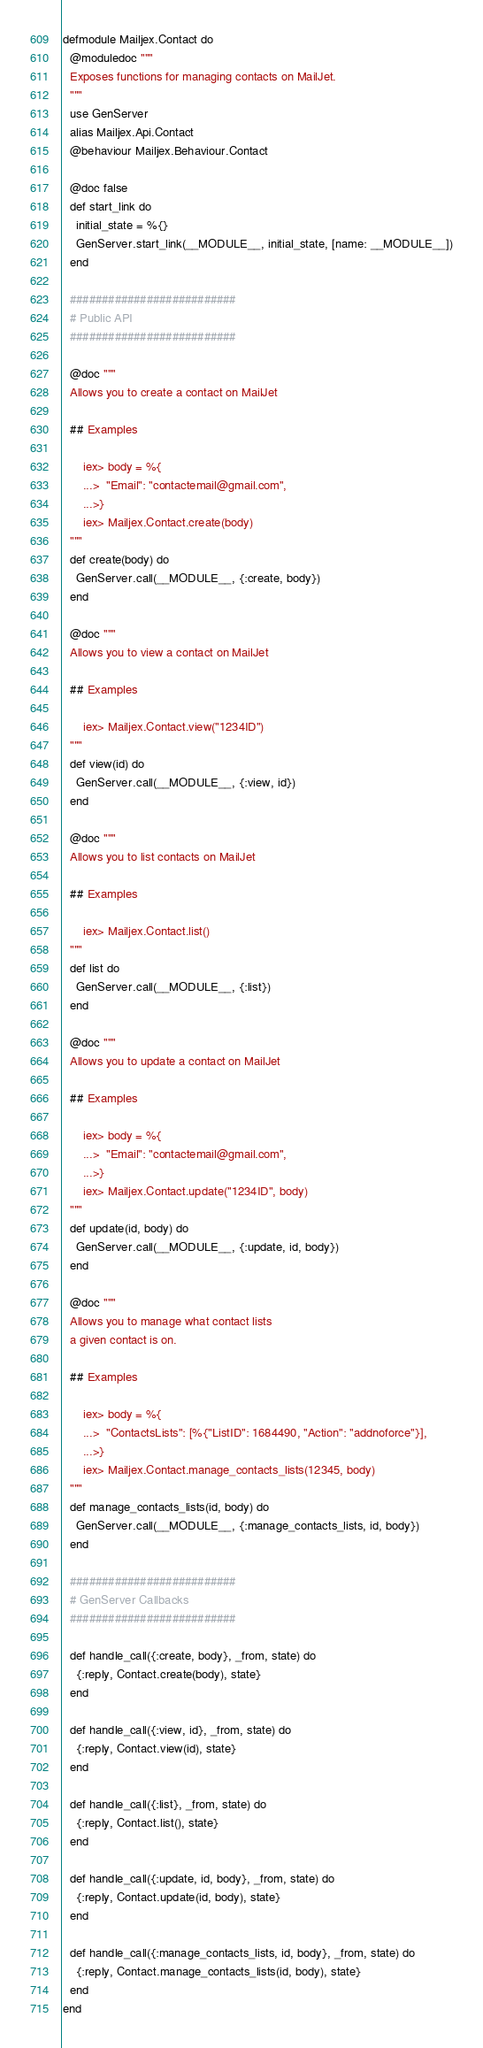Convert code to text. <code><loc_0><loc_0><loc_500><loc_500><_Elixir_>defmodule Mailjex.Contact do
  @moduledoc """
  Exposes functions for managing contacts on MailJet.
  """
  use GenServer
  alias Mailjex.Api.Contact
  @behaviour Mailjex.Behaviour.Contact

  @doc false
  def start_link do
    initial_state = %{}
    GenServer.start_link(__MODULE__, initial_state, [name: __MODULE__])
  end

  ##########################
  # Public API
  ##########################

  @doc """
  Allows you to create a contact on MailJet

  ## Examples

      iex> body = %{
      ...>  "Email": "contactemail@gmail.com",
      ...>}
      iex> Mailjex.Contact.create(body)
  """
  def create(body) do
    GenServer.call(__MODULE__, {:create, body})
  end

  @doc """
  Allows you to view a contact on MailJet

  ## Examples

      iex> Mailjex.Contact.view("1234ID")
  """
  def view(id) do
    GenServer.call(__MODULE__, {:view, id})
  end

  @doc """
  Allows you to list contacts on MailJet

  ## Examples

      iex> Mailjex.Contact.list()
  """
  def list do
    GenServer.call(__MODULE__, {:list})
  end

  @doc """
  Allows you to update a contact on MailJet

  ## Examples

      iex> body = %{
      ...>  "Email": "contactemail@gmail.com",
      ...>}
      iex> Mailjex.Contact.update("1234ID", body)
  """
  def update(id, body) do
    GenServer.call(__MODULE__, {:update, id, body})
  end

  @doc """
  Allows you to manage what contact lists
  a given contact is on.

  ## Examples

      iex> body = %{
      ...>  "ContactsLists": [%{"ListID": 1684490, "Action": "addnoforce"}],
      ...>}
      iex> Mailjex.Contact.manage_contacts_lists(12345, body)
  """
  def manage_contacts_lists(id, body) do
    GenServer.call(__MODULE__, {:manage_contacts_lists, id, body})
  end

  ##########################
  # GenServer Callbacks
  ##########################

  def handle_call({:create, body}, _from, state) do
    {:reply, Contact.create(body), state}
  end

  def handle_call({:view, id}, _from, state) do
    {:reply, Contact.view(id), state}
  end

  def handle_call({:list}, _from, state) do
    {:reply, Contact.list(), state}
  end

  def handle_call({:update, id, body}, _from, state) do
    {:reply, Contact.update(id, body), state}
  end

  def handle_call({:manage_contacts_lists, id, body}, _from, state) do
    {:reply, Contact.manage_contacts_lists(id, body), state}
  end
end
</code> 